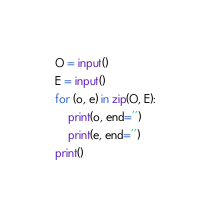Convert code to text. <code><loc_0><loc_0><loc_500><loc_500><_Python_>O = input()
E = input()
for (o, e) in zip(O, E):
    print(o, end='')
    print(e, end='')
print()</code> 